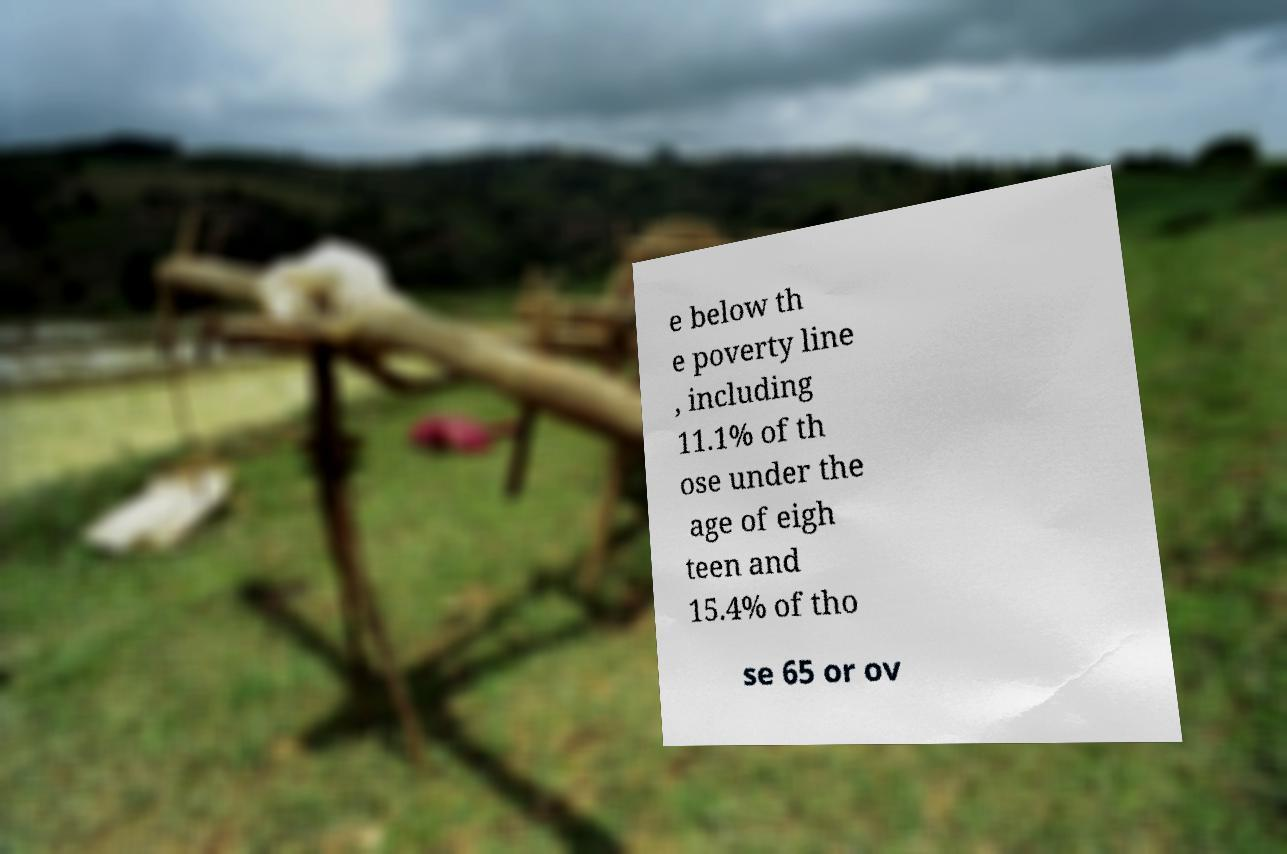Could you assist in decoding the text presented in this image and type it out clearly? e below th e poverty line , including 11.1% of th ose under the age of eigh teen and 15.4% of tho se 65 or ov 